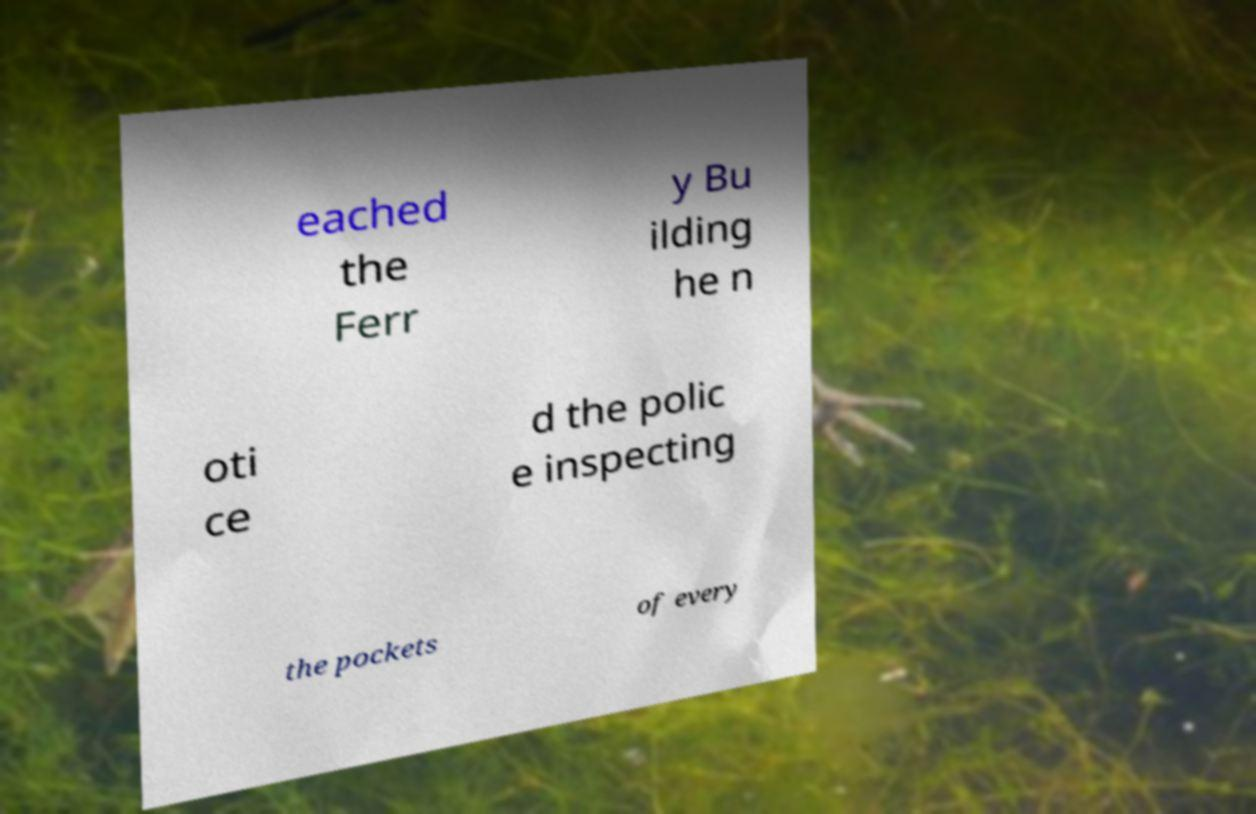Can you read and provide the text displayed in the image?This photo seems to have some interesting text. Can you extract and type it out for me? eached the Ferr y Bu ilding he n oti ce d the polic e inspecting the pockets of every 